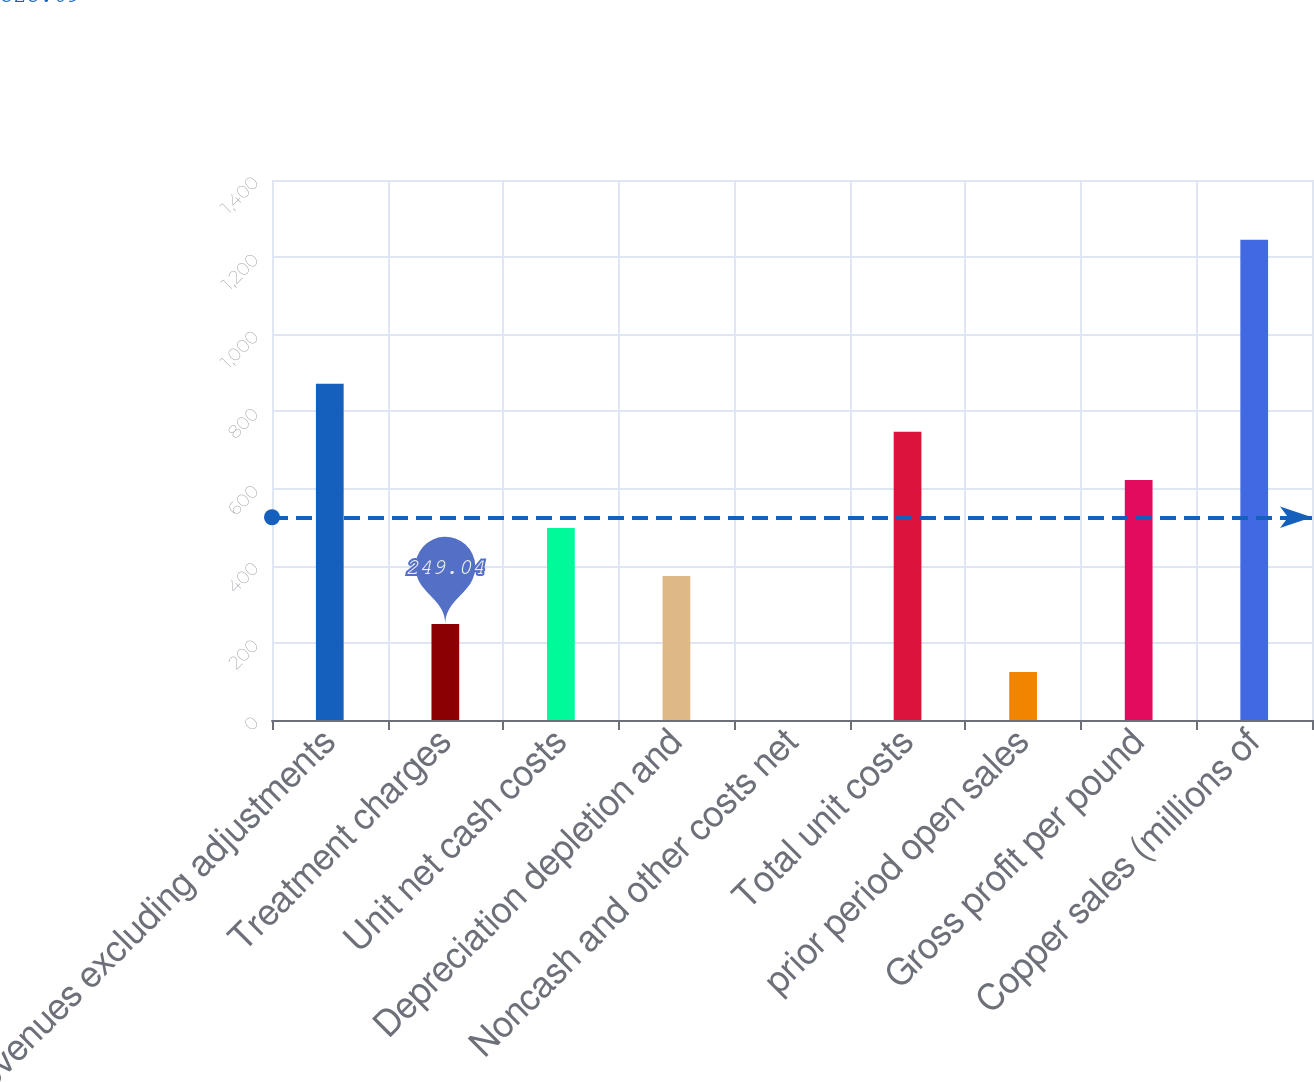Convert chart. <chart><loc_0><loc_0><loc_500><loc_500><bar_chart><fcel>Revenues excluding adjustments<fcel>Treatment charges<fcel>Unit net cash costs<fcel>Depreciation depletion and<fcel>Noncash and other costs net<fcel>Total unit costs<fcel>prior period open sales<fcel>Gross profit per pound<fcel>Copper sales (millions of<nl><fcel>871.49<fcel>249.04<fcel>498.02<fcel>373.53<fcel>0.06<fcel>747<fcel>124.55<fcel>622.51<fcel>1245<nl></chart> 